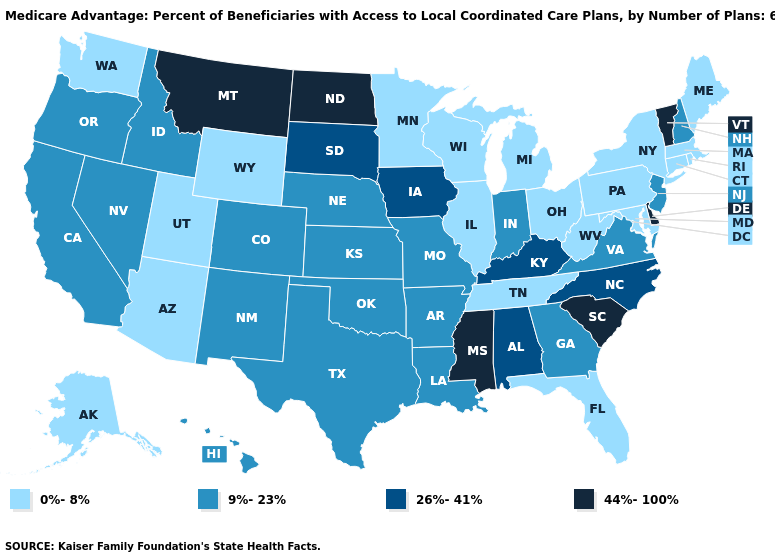Name the states that have a value in the range 44%-100%?
Give a very brief answer. Delaware, Mississippi, Montana, North Dakota, South Carolina, Vermont. What is the lowest value in the USA?
Concise answer only. 0%-8%. Which states have the highest value in the USA?
Answer briefly. Delaware, Mississippi, Montana, North Dakota, South Carolina, Vermont. What is the value of Vermont?
Answer briefly. 44%-100%. Which states have the lowest value in the USA?
Be succinct. Connecticut, Florida, Illinois, Massachusetts, Maryland, Maine, Michigan, Minnesota, New York, Ohio, Pennsylvania, Rhode Island, Alaska, Tennessee, Utah, Washington, Wisconsin, West Virginia, Wyoming, Arizona. What is the highest value in the MidWest ?
Answer briefly. 44%-100%. Does Kansas have a lower value than Iowa?
Write a very short answer. Yes. What is the value of Connecticut?
Concise answer only. 0%-8%. Does the first symbol in the legend represent the smallest category?
Quick response, please. Yes. What is the value of Mississippi?
Write a very short answer. 44%-100%. Does Ohio have the lowest value in the MidWest?
Keep it brief. Yes. Which states have the highest value in the USA?
Keep it brief. Delaware, Mississippi, Montana, North Dakota, South Carolina, Vermont. Does Texas have the highest value in the USA?
Concise answer only. No. Name the states that have a value in the range 26%-41%?
Quick response, please. Iowa, Kentucky, North Carolina, South Dakota, Alabama. 